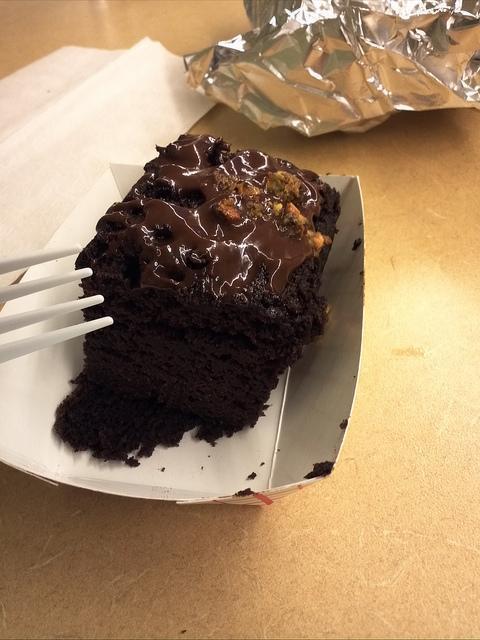How many forks are there?
Give a very brief answer. 1. How many ax signs are to the left of the woman on the bench?
Give a very brief answer. 0. 